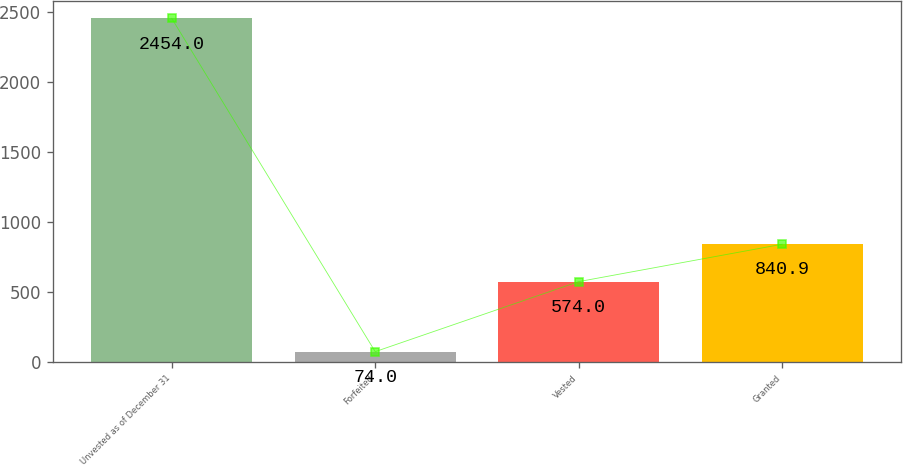<chart> <loc_0><loc_0><loc_500><loc_500><bar_chart><fcel>Unvested as of December 31<fcel>Forfeited<fcel>Vested<fcel>Granted<nl><fcel>2454<fcel>74<fcel>574<fcel>840.9<nl></chart> 